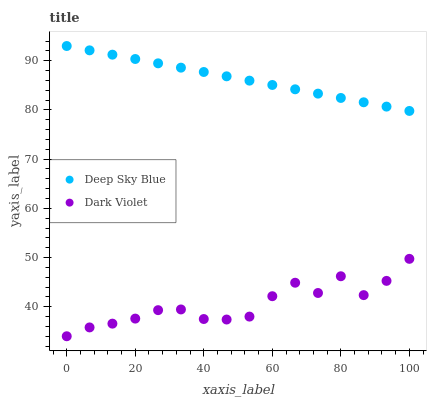Does Dark Violet have the minimum area under the curve?
Answer yes or no. Yes. Does Deep Sky Blue have the maximum area under the curve?
Answer yes or no. Yes. Does Deep Sky Blue have the minimum area under the curve?
Answer yes or no. No. Is Deep Sky Blue the smoothest?
Answer yes or no. Yes. Is Dark Violet the roughest?
Answer yes or no. Yes. Is Deep Sky Blue the roughest?
Answer yes or no. No. Does Dark Violet have the lowest value?
Answer yes or no. Yes. Does Deep Sky Blue have the lowest value?
Answer yes or no. No. Does Deep Sky Blue have the highest value?
Answer yes or no. Yes. Is Dark Violet less than Deep Sky Blue?
Answer yes or no. Yes. Is Deep Sky Blue greater than Dark Violet?
Answer yes or no. Yes. Does Dark Violet intersect Deep Sky Blue?
Answer yes or no. No. 